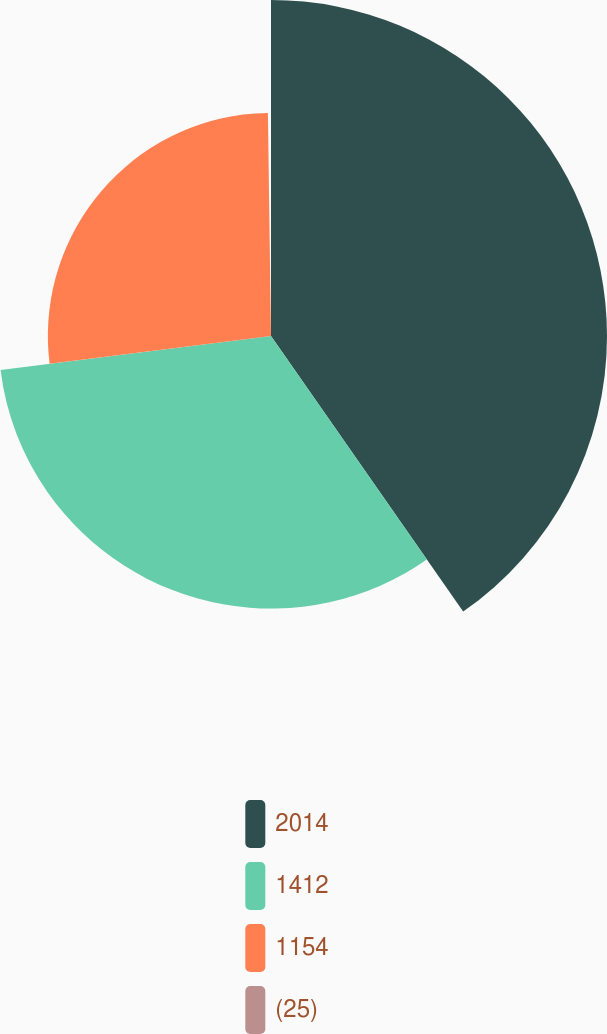<chart> <loc_0><loc_0><loc_500><loc_500><pie_chart><fcel>2014<fcel>1412<fcel>1154<fcel>(25)<nl><fcel>40.31%<fcel>32.7%<fcel>26.77%<fcel>0.22%<nl></chart> 